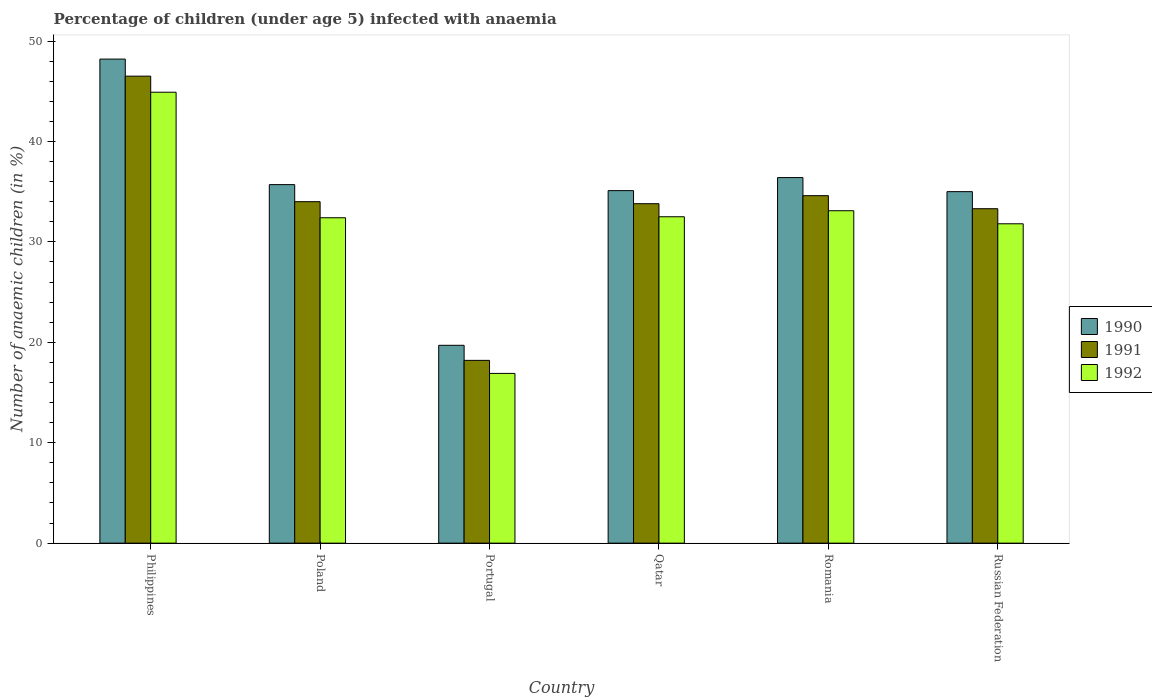How many different coloured bars are there?
Your answer should be compact. 3. Are the number of bars on each tick of the X-axis equal?
Make the answer very short. Yes. How many bars are there on the 1st tick from the left?
Give a very brief answer. 3. How many bars are there on the 3rd tick from the right?
Keep it short and to the point. 3. What is the label of the 6th group of bars from the left?
Provide a succinct answer. Russian Federation. What is the percentage of children infected with anaemia in in 1991 in Romania?
Keep it short and to the point. 34.6. Across all countries, what is the maximum percentage of children infected with anaemia in in 1992?
Give a very brief answer. 44.9. What is the total percentage of children infected with anaemia in in 1991 in the graph?
Offer a very short reply. 200.4. What is the difference between the percentage of children infected with anaemia in in 1992 in Poland and that in Russian Federation?
Offer a very short reply. 0.6. What is the difference between the percentage of children infected with anaemia in in 1991 in Romania and the percentage of children infected with anaemia in in 1990 in Philippines?
Ensure brevity in your answer.  -13.6. What is the average percentage of children infected with anaemia in in 1990 per country?
Keep it short and to the point. 35.02. What is the difference between the percentage of children infected with anaemia in of/in 1991 and percentage of children infected with anaemia in of/in 1990 in Poland?
Provide a short and direct response. -1.7. What is the ratio of the percentage of children infected with anaemia in in 1990 in Philippines to that in Russian Federation?
Make the answer very short. 1.38. What is the difference between the highest and the second highest percentage of children infected with anaemia in in 1990?
Offer a terse response. 12.5. What is the difference between the highest and the lowest percentage of children infected with anaemia in in 1990?
Offer a terse response. 28.5. What does the 2nd bar from the right in Qatar represents?
Make the answer very short. 1991. Are all the bars in the graph horizontal?
Ensure brevity in your answer.  No. How many countries are there in the graph?
Offer a terse response. 6. What is the difference between two consecutive major ticks on the Y-axis?
Make the answer very short. 10. Are the values on the major ticks of Y-axis written in scientific E-notation?
Offer a terse response. No. Does the graph contain any zero values?
Your answer should be compact. No. Does the graph contain grids?
Provide a short and direct response. No. How are the legend labels stacked?
Your answer should be compact. Vertical. What is the title of the graph?
Keep it short and to the point. Percentage of children (under age 5) infected with anaemia. Does "1968" appear as one of the legend labels in the graph?
Your response must be concise. No. What is the label or title of the Y-axis?
Your response must be concise. Number of anaemic children (in %). What is the Number of anaemic children (in %) in 1990 in Philippines?
Provide a short and direct response. 48.2. What is the Number of anaemic children (in %) of 1991 in Philippines?
Offer a very short reply. 46.5. What is the Number of anaemic children (in %) of 1992 in Philippines?
Give a very brief answer. 44.9. What is the Number of anaemic children (in %) of 1990 in Poland?
Offer a very short reply. 35.7. What is the Number of anaemic children (in %) of 1991 in Poland?
Offer a very short reply. 34. What is the Number of anaemic children (in %) in 1992 in Poland?
Provide a succinct answer. 32.4. What is the Number of anaemic children (in %) in 1990 in Portugal?
Your response must be concise. 19.7. What is the Number of anaemic children (in %) in 1991 in Portugal?
Provide a succinct answer. 18.2. What is the Number of anaemic children (in %) of 1990 in Qatar?
Offer a very short reply. 35.1. What is the Number of anaemic children (in %) of 1991 in Qatar?
Offer a terse response. 33.8. What is the Number of anaemic children (in %) of 1992 in Qatar?
Offer a very short reply. 32.5. What is the Number of anaemic children (in %) of 1990 in Romania?
Ensure brevity in your answer.  36.4. What is the Number of anaemic children (in %) of 1991 in Romania?
Make the answer very short. 34.6. What is the Number of anaemic children (in %) of 1992 in Romania?
Offer a terse response. 33.1. What is the Number of anaemic children (in %) in 1991 in Russian Federation?
Keep it short and to the point. 33.3. What is the Number of anaemic children (in %) in 1992 in Russian Federation?
Provide a succinct answer. 31.8. Across all countries, what is the maximum Number of anaemic children (in %) in 1990?
Provide a succinct answer. 48.2. Across all countries, what is the maximum Number of anaemic children (in %) of 1991?
Your answer should be very brief. 46.5. Across all countries, what is the maximum Number of anaemic children (in %) in 1992?
Ensure brevity in your answer.  44.9. Across all countries, what is the minimum Number of anaemic children (in %) of 1990?
Keep it short and to the point. 19.7. What is the total Number of anaemic children (in %) of 1990 in the graph?
Your response must be concise. 210.1. What is the total Number of anaemic children (in %) of 1991 in the graph?
Provide a short and direct response. 200.4. What is the total Number of anaemic children (in %) in 1992 in the graph?
Your answer should be compact. 191.6. What is the difference between the Number of anaemic children (in %) in 1991 in Philippines and that in Poland?
Make the answer very short. 12.5. What is the difference between the Number of anaemic children (in %) of 1992 in Philippines and that in Poland?
Make the answer very short. 12.5. What is the difference between the Number of anaemic children (in %) in 1990 in Philippines and that in Portugal?
Make the answer very short. 28.5. What is the difference between the Number of anaemic children (in %) of 1991 in Philippines and that in Portugal?
Your answer should be very brief. 28.3. What is the difference between the Number of anaemic children (in %) of 1992 in Philippines and that in Portugal?
Your response must be concise. 28. What is the difference between the Number of anaemic children (in %) of 1992 in Philippines and that in Qatar?
Offer a terse response. 12.4. What is the difference between the Number of anaemic children (in %) of 1990 in Philippines and that in Romania?
Provide a short and direct response. 11.8. What is the difference between the Number of anaemic children (in %) in 1991 in Philippines and that in Russian Federation?
Provide a succinct answer. 13.2. What is the difference between the Number of anaemic children (in %) of 1992 in Philippines and that in Russian Federation?
Ensure brevity in your answer.  13.1. What is the difference between the Number of anaemic children (in %) in 1990 in Poland and that in Portugal?
Provide a short and direct response. 16. What is the difference between the Number of anaemic children (in %) of 1991 in Poland and that in Portugal?
Provide a short and direct response. 15.8. What is the difference between the Number of anaemic children (in %) of 1991 in Poland and that in Qatar?
Offer a very short reply. 0.2. What is the difference between the Number of anaemic children (in %) in 1992 in Poland and that in Qatar?
Your answer should be compact. -0.1. What is the difference between the Number of anaemic children (in %) of 1990 in Poland and that in Romania?
Give a very brief answer. -0.7. What is the difference between the Number of anaemic children (in %) of 1991 in Poland and that in Romania?
Your answer should be very brief. -0.6. What is the difference between the Number of anaemic children (in %) of 1992 in Poland and that in Romania?
Provide a short and direct response. -0.7. What is the difference between the Number of anaemic children (in %) in 1991 in Poland and that in Russian Federation?
Make the answer very short. 0.7. What is the difference between the Number of anaemic children (in %) in 1990 in Portugal and that in Qatar?
Ensure brevity in your answer.  -15.4. What is the difference between the Number of anaemic children (in %) in 1991 in Portugal and that in Qatar?
Provide a succinct answer. -15.6. What is the difference between the Number of anaemic children (in %) in 1992 in Portugal and that in Qatar?
Your answer should be compact. -15.6. What is the difference between the Number of anaemic children (in %) of 1990 in Portugal and that in Romania?
Your response must be concise. -16.7. What is the difference between the Number of anaemic children (in %) of 1991 in Portugal and that in Romania?
Your answer should be very brief. -16.4. What is the difference between the Number of anaemic children (in %) in 1992 in Portugal and that in Romania?
Keep it short and to the point. -16.2. What is the difference between the Number of anaemic children (in %) in 1990 in Portugal and that in Russian Federation?
Make the answer very short. -15.3. What is the difference between the Number of anaemic children (in %) in 1991 in Portugal and that in Russian Federation?
Your response must be concise. -15.1. What is the difference between the Number of anaemic children (in %) in 1992 in Portugal and that in Russian Federation?
Give a very brief answer. -14.9. What is the difference between the Number of anaemic children (in %) of 1990 in Qatar and that in Romania?
Your response must be concise. -1.3. What is the difference between the Number of anaemic children (in %) of 1992 in Qatar and that in Russian Federation?
Offer a terse response. 0.7. What is the difference between the Number of anaemic children (in %) in 1990 in Romania and that in Russian Federation?
Offer a terse response. 1.4. What is the difference between the Number of anaemic children (in %) of 1990 in Philippines and the Number of anaemic children (in %) of 1991 in Poland?
Your answer should be compact. 14.2. What is the difference between the Number of anaemic children (in %) of 1990 in Philippines and the Number of anaemic children (in %) of 1992 in Portugal?
Your answer should be compact. 31.3. What is the difference between the Number of anaemic children (in %) in 1991 in Philippines and the Number of anaemic children (in %) in 1992 in Portugal?
Keep it short and to the point. 29.6. What is the difference between the Number of anaemic children (in %) of 1990 in Philippines and the Number of anaemic children (in %) of 1991 in Qatar?
Give a very brief answer. 14.4. What is the difference between the Number of anaemic children (in %) of 1990 in Philippines and the Number of anaemic children (in %) of 1992 in Qatar?
Your answer should be very brief. 15.7. What is the difference between the Number of anaemic children (in %) in 1991 in Philippines and the Number of anaemic children (in %) in 1992 in Qatar?
Offer a terse response. 14. What is the difference between the Number of anaemic children (in %) of 1990 in Philippines and the Number of anaemic children (in %) of 1991 in Romania?
Provide a succinct answer. 13.6. What is the difference between the Number of anaemic children (in %) in 1990 in Philippines and the Number of anaemic children (in %) in 1992 in Russian Federation?
Offer a very short reply. 16.4. What is the difference between the Number of anaemic children (in %) in 1991 in Philippines and the Number of anaemic children (in %) in 1992 in Russian Federation?
Provide a short and direct response. 14.7. What is the difference between the Number of anaemic children (in %) in 1990 in Poland and the Number of anaemic children (in %) in 1992 in Qatar?
Offer a very short reply. 3.2. What is the difference between the Number of anaemic children (in %) in 1990 in Poland and the Number of anaemic children (in %) in 1991 in Romania?
Keep it short and to the point. 1.1. What is the difference between the Number of anaemic children (in %) in 1990 in Poland and the Number of anaemic children (in %) in 1992 in Russian Federation?
Your answer should be very brief. 3.9. What is the difference between the Number of anaemic children (in %) of 1991 in Poland and the Number of anaemic children (in %) of 1992 in Russian Federation?
Provide a short and direct response. 2.2. What is the difference between the Number of anaemic children (in %) of 1990 in Portugal and the Number of anaemic children (in %) of 1991 in Qatar?
Your answer should be very brief. -14.1. What is the difference between the Number of anaemic children (in %) of 1991 in Portugal and the Number of anaemic children (in %) of 1992 in Qatar?
Give a very brief answer. -14.3. What is the difference between the Number of anaemic children (in %) of 1990 in Portugal and the Number of anaemic children (in %) of 1991 in Romania?
Ensure brevity in your answer.  -14.9. What is the difference between the Number of anaemic children (in %) in 1990 in Portugal and the Number of anaemic children (in %) in 1992 in Romania?
Offer a terse response. -13.4. What is the difference between the Number of anaemic children (in %) of 1991 in Portugal and the Number of anaemic children (in %) of 1992 in Romania?
Ensure brevity in your answer.  -14.9. What is the difference between the Number of anaemic children (in %) of 1990 in Portugal and the Number of anaemic children (in %) of 1991 in Russian Federation?
Offer a terse response. -13.6. What is the difference between the Number of anaemic children (in %) in 1990 in Qatar and the Number of anaemic children (in %) in 1991 in Romania?
Your answer should be compact. 0.5. What is the difference between the Number of anaemic children (in %) of 1990 in Qatar and the Number of anaemic children (in %) of 1992 in Russian Federation?
Give a very brief answer. 3.3. What is the difference between the Number of anaemic children (in %) of 1991 in Qatar and the Number of anaemic children (in %) of 1992 in Russian Federation?
Give a very brief answer. 2. What is the difference between the Number of anaemic children (in %) of 1990 in Romania and the Number of anaemic children (in %) of 1991 in Russian Federation?
Offer a terse response. 3.1. What is the average Number of anaemic children (in %) of 1990 per country?
Offer a very short reply. 35.02. What is the average Number of anaemic children (in %) in 1991 per country?
Ensure brevity in your answer.  33.4. What is the average Number of anaemic children (in %) in 1992 per country?
Offer a very short reply. 31.93. What is the difference between the Number of anaemic children (in %) of 1990 and Number of anaemic children (in %) of 1992 in Philippines?
Your response must be concise. 3.3. What is the difference between the Number of anaemic children (in %) in 1991 and Number of anaemic children (in %) in 1992 in Philippines?
Your response must be concise. 1.6. What is the difference between the Number of anaemic children (in %) of 1990 and Number of anaemic children (in %) of 1991 in Poland?
Keep it short and to the point. 1.7. What is the difference between the Number of anaemic children (in %) of 1990 and Number of anaemic children (in %) of 1992 in Poland?
Offer a terse response. 3.3. What is the difference between the Number of anaemic children (in %) of 1991 and Number of anaemic children (in %) of 1992 in Poland?
Your response must be concise. 1.6. What is the difference between the Number of anaemic children (in %) in 1990 and Number of anaemic children (in %) in 1991 in Portugal?
Keep it short and to the point. 1.5. What is the difference between the Number of anaemic children (in %) of 1990 and Number of anaemic children (in %) of 1992 in Portugal?
Ensure brevity in your answer.  2.8. What is the difference between the Number of anaemic children (in %) of 1990 and Number of anaemic children (in %) of 1991 in Qatar?
Your answer should be compact. 1.3. What is the difference between the Number of anaemic children (in %) in 1990 and Number of anaemic children (in %) in 1992 in Russian Federation?
Offer a very short reply. 3.2. What is the difference between the Number of anaemic children (in %) in 1991 and Number of anaemic children (in %) in 1992 in Russian Federation?
Offer a very short reply. 1.5. What is the ratio of the Number of anaemic children (in %) in 1990 in Philippines to that in Poland?
Offer a terse response. 1.35. What is the ratio of the Number of anaemic children (in %) in 1991 in Philippines to that in Poland?
Provide a short and direct response. 1.37. What is the ratio of the Number of anaemic children (in %) of 1992 in Philippines to that in Poland?
Your answer should be compact. 1.39. What is the ratio of the Number of anaemic children (in %) of 1990 in Philippines to that in Portugal?
Offer a very short reply. 2.45. What is the ratio of the Number of anaemic children (in %) in 1991 in Philippines to that in Portugal?
Your answer should be very brief. 2.55. What is the ratio of the Number of anaemic children (in %) of 1992 in Philippines to that in Portugal?
Give a very brief answer. 2.66. What is the ratio of the Number of anaemic children (in %) in 1990 in Philippines to that in Qatar?
Give a very brief answer. 1.37. What is the ratio of the Number of anaemic children (in %) in 1991 in Philippines to that in Qatar?
Your answer should be compact. 1.38. What is the ratio of the Number of anaemic children (in %) in 1992 in Philippines to that in Qatar?
Your response must be concise. 1.38. What is the ratio of the Number of anaemic children (in %) in 1990 in Philippines to that in Romania?
Offer a very short reply. 1.32. What is the ratio of the Number of anaemic children (in %) in 1991 in Philippines to that in Romania?
Your answer should be very brief. 1.34. What is the ratio of the Number of anaemic children (in %) in 1992 in Philippines to that in Romania?
Your response must be concise. 1.36. What is the ratio of the Number of anaemic children (in %) of 1990 in Philippines to that in Russian Federation?
Offer a very short reply. 1.38. What is the ratio of the Number of anaemic children (in %) in 1991 in Philippines to that in Russian Federation?
Provide a short and direct response. 1.4. What is the ratio of the Number of anaemic children (in %) of 1992 in Philippines to that in Russian Federation?
Keep it short and to the point. 1.41. What is the ratio of the Number of anaemic children (in %) of 1990 in Poland to that in Portugal?
Your answer should be very brief. 1.81. What is the ratio of the Number of anaemic children (in %) in 1991 in Poland to that in Portugal?
Keep it short and to the point. 1.87. What is the ratio of the Number of anaemic children (in %) of 1992 in Poland to that in Portugal?
Offer a terse response. 1.92. What is the ratio of the Number of anaemic children (in %) in 1990 in Poland to that in Qatar?
Provide a succinct answer. 1.02. What is the ratio of the Number of anaemic children (in %) of 1991 in Poland to that in Qatar?
Make the answer very short. 1.01. What is the ratio of the Number of anaemic children (in %) of 1990 in Poland to that in Romania?
Give a very brief answer. 0.98. What is the ratio of the Number of anaemic children (in %) of 1991 in Poland to that in Romania?
Offer a terse response. 0.98. What is the ratio of the Number of anaemic children (in %) of 1992 in Poland to that in Romania?
Offer a very short reply. 0.98. What is the ratio of the Number of anaemic children (in %) of 1990 in Poland to that in Russian Federation?
Your response must be concise. 1.02. What is the ratio of the Number of anaemic children (in %) in 1992 in Poland to that in Russian Federation?
Offer a very short reply. 1.02. What is the ratio of the Number of anaemic children (in %) of 1990 in Portugal to that in Qatar?
Offer a terse response. 0.56. What is the ratio of the Number of anaemic children (in %) in 1991 in Portugal to that in Qatar?
Offer a very short reply. 0.54. What is the ratio of the Number of anaemic children (in %) of 1992 in Portugal to that in Qatar?
Provide a succinct answer. 0.52. What is the ratio of the Number of anaemic children (in %) of 1990 in Portugal to that in Romania?
Keep it short and to the point. 0.54. What is the ratio of the Number of anaemic children (in %) of 1991 in Portugal to that in Romania?
Keep it short and to the point. 0.53. What is the ratio of the Number of anaemic children (in %) in 1992 in Portugal to that in Romania?
Ensure brevity in your answer.  0.51. What is the ratio of the Number of anaemic children (in %) of 1990 in Portugal to that in Russian Federation?
Ensure brevity in your answer.  0.56. What is the ratio of the Number of anaemic children (in %) of 1991 in Portugal to that in Russian Federation?
Give a very brief answer. 0.55. What is the ratio of the Number of anaemic children (in %) in 1992 in Portugal to that in Russian Federation?
Your answer should be compact. 0.53. What is the ratio of the Number of anaemic children (in %) in 1991 in Qatar to that in Romania?
Make the answer very short. 0.98. What is the ratio of the Number of anaemic children (in %) of 1992 in Qatar to that in Romania?
Provide a short and direct response. 0.98. What is the ratio of the Number of anaemic children (in %) in 1992 in Qatar to that in Russian Federation?
Provide a short and direct response. 1.02. What is the ratio of the Number of anaemic children (in %) of 1991 in Romania to that in Russian Federation?
Your answer should be very brief. 1.04. What is the ratio of the Number of anaemic children (in %) in 1992 in Romania to that in Russian Federation?
Provide a succinct answer. 1.04. What is the difference between the highest and the lowest Number of anaemic children (in %) in 1991?
Ensure brevity in your answer.  28.3. What is the difference between the highest and the lowest Number of anaemic children (in %) of 1992?
Offer a very short reply. 28. 